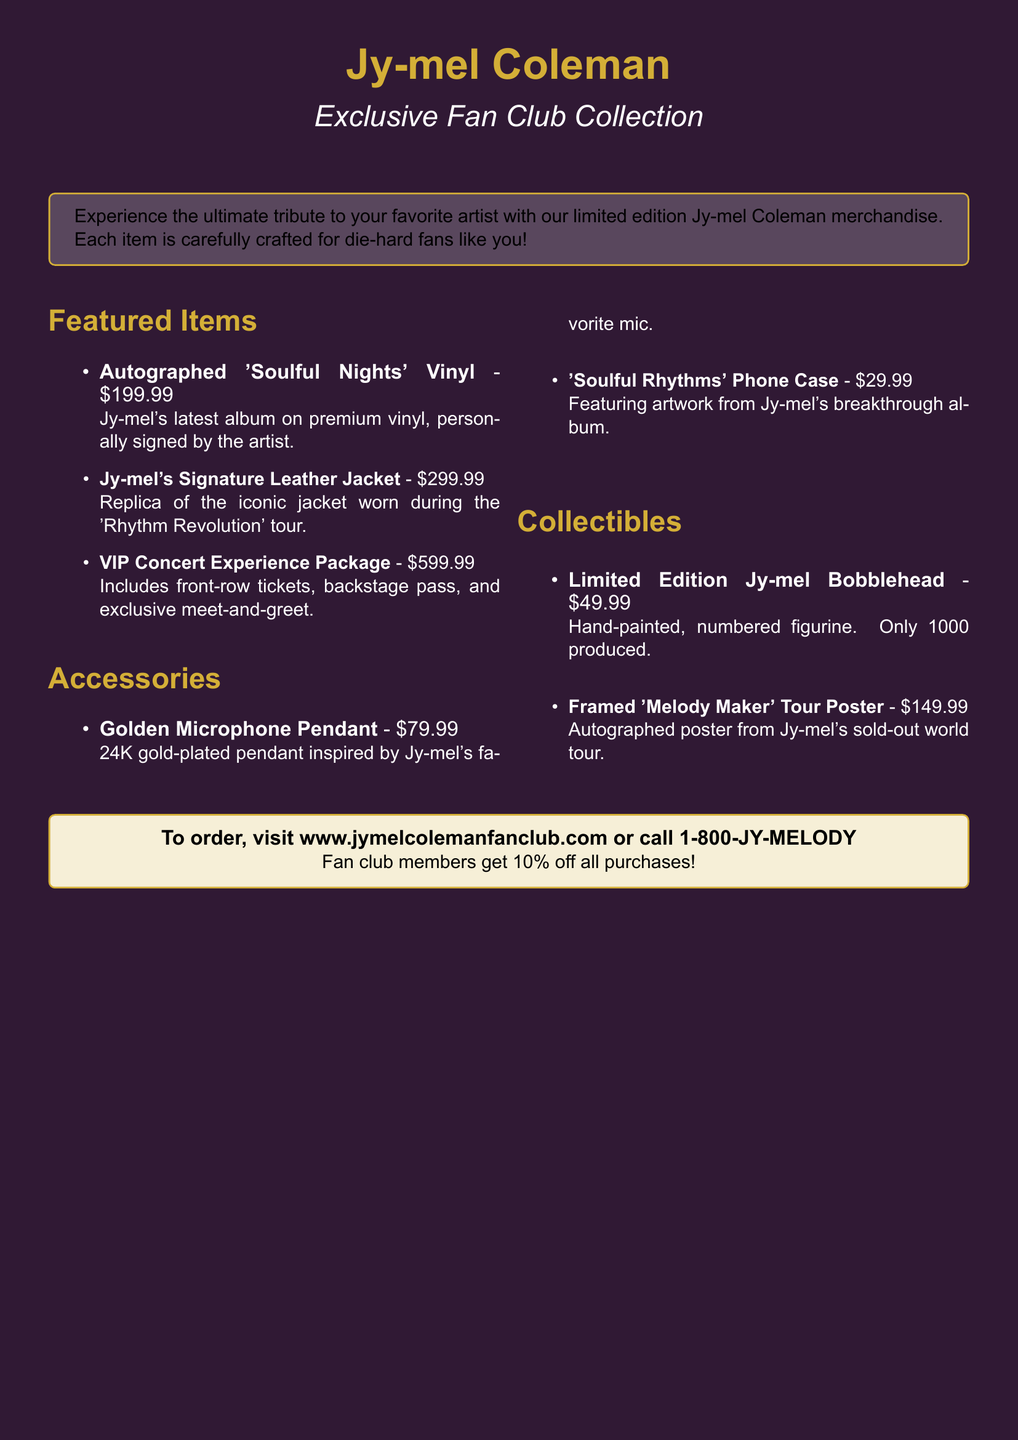What is the price of the autographed vinyl? The price is clearly listed in the document under "Featured Items" as $199.99.
Answer: $199.99 How many items are in the collectibles section? The number of items can be easily counted in the "Collectibles" section of the document, which lists two items.
Answer: 2 What is the name of the product inspired by Jy-mel's favorite mic? This is specified in the "Accessories" section, identifying the product as the "Golden Microphone Pendant."
Answer: Golden Microphone Pendant What is the discount percentage for fan club members? The document mentions that fan club members receive a discount of 10%.
Answer: 10% What is the price of the VIP Concert Experience Package? The document directly states that the price of this package is $599.99 under "Featured Items."
Answer: $599.99 How many Limited Edition Jy-mel Bobbleheads were produced? The document states that only 1000 of these bobbleheads were made.
Answer: 1000 What is the total number of sections in the catalog? The content can be easily summarized by counting the main sections listed: "Featured Items," "Accessories," and "Collectibles," totaling three sections.
Answer: 3 What unique feature does the "Soulful Rhythms" Phone Case have? The document notes that it features artwork from Jy-mel's breakthrough album, indicating its unique design.
Answer: Artwork from breakthrough album 